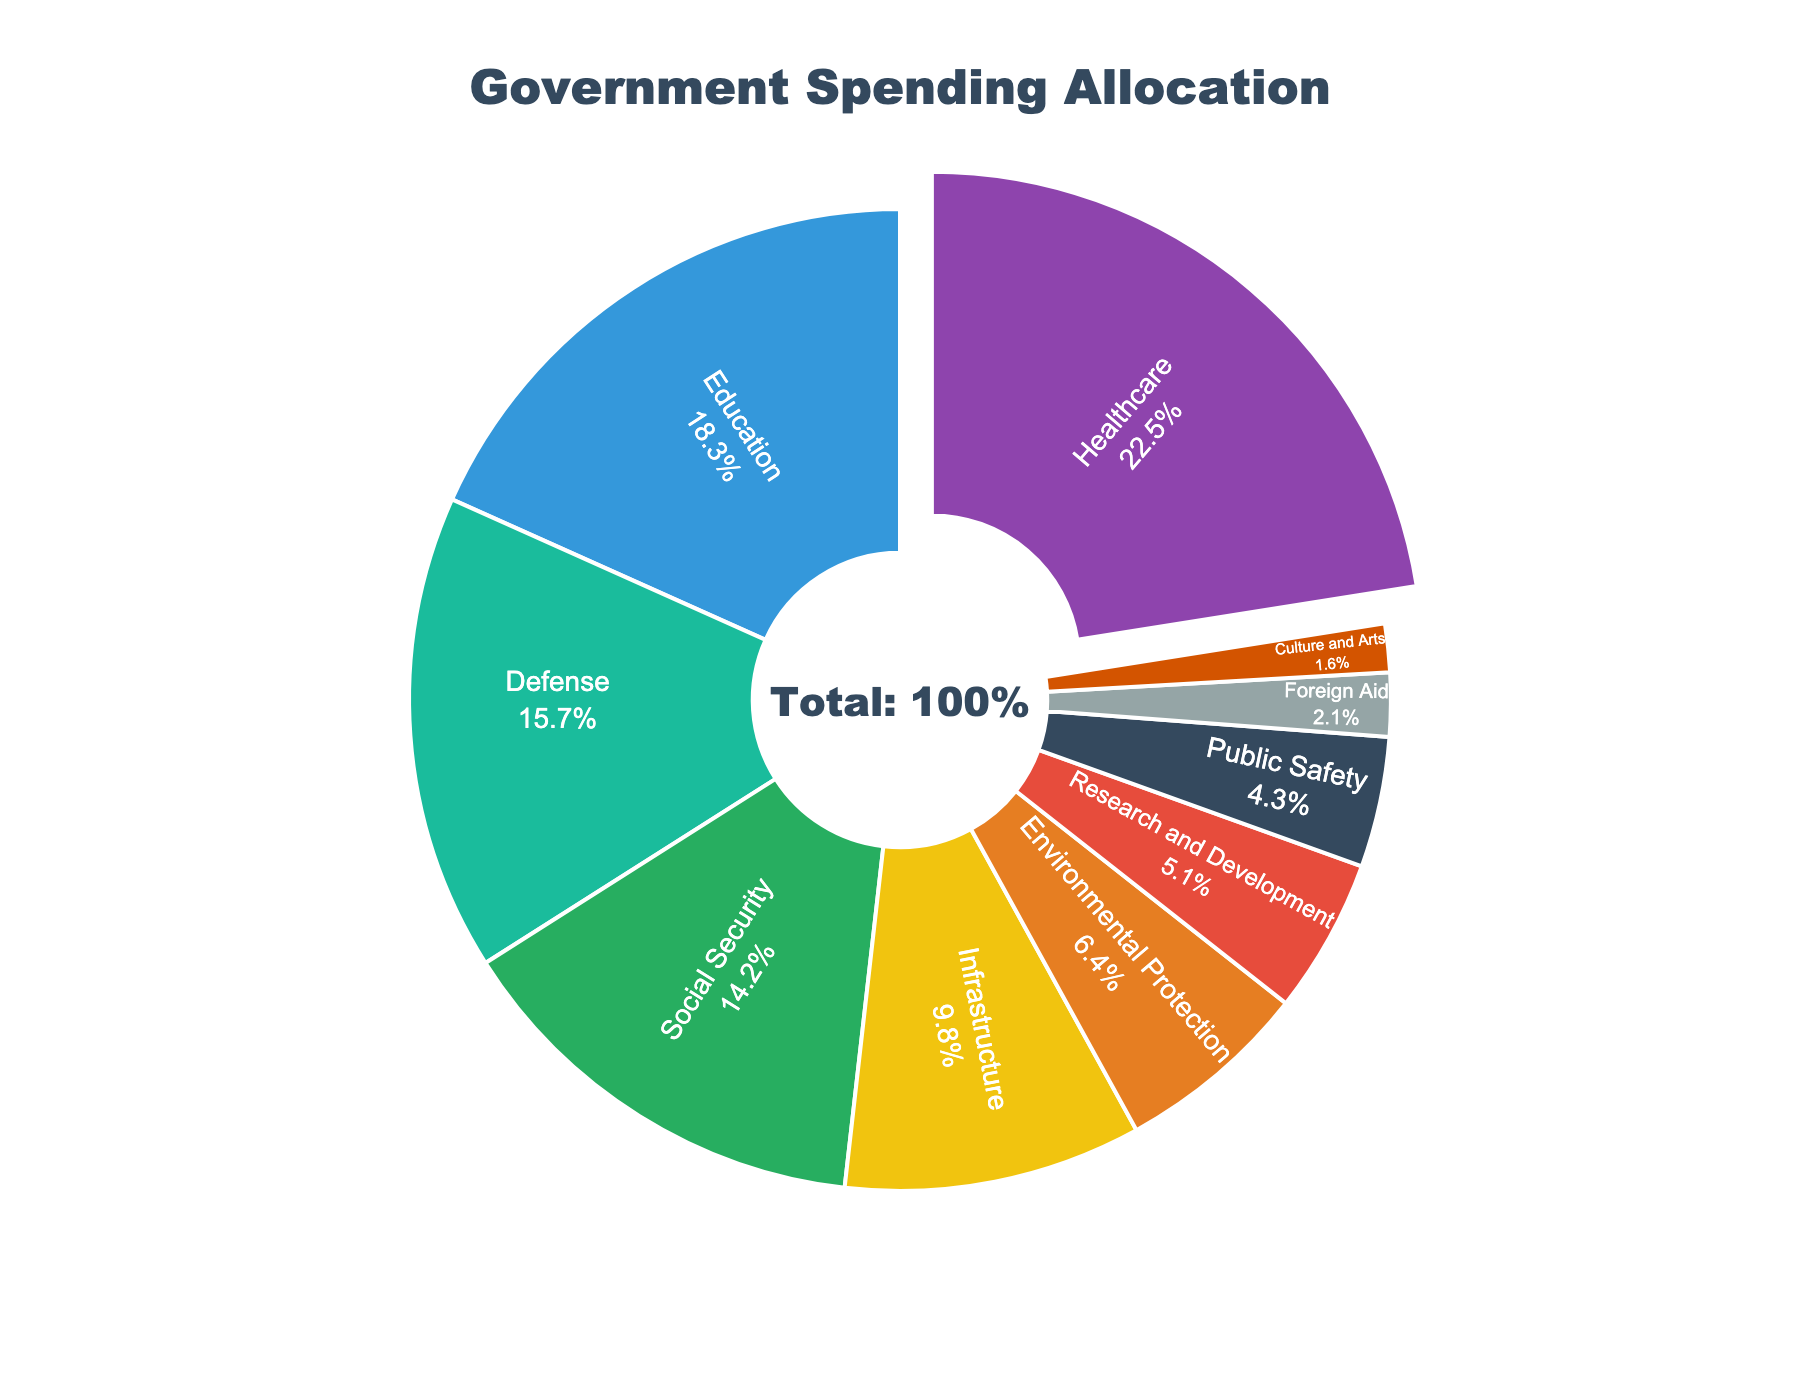What's the total percentage of spending on Education and Healthcare combined? To find the combined percentage, add the percentages of Education (18.3%) and Healthcare (22.5%). This gives 18.3 + 22.5 = 40.8%.
Answer: 40.8% Which sector receives the least amount of funding? Look at the sectors and their allocated percentages to find the smallest percentage value. Culture and Arts has the smallest allocation at 1.6%.
Answer: Culture and Arts Is more money spent on Defense or Social Security? Compare the percentage values for Defense (15.7%) and Social Security (14.2%). Defense has a higher percentage.
Answer: Defense What is the percentage difference between Infrastructure and Research and Development spending? Subtract the percentage of Research and Development (5.1%) from Infrastructure (9.8%). 9.8 - 5.1 = 4.7
Answer: 4.7% Which sector's slice is visually the largest, and by how much is it larger than the second-largest sector? By visually inspecting the pie chart, the Healthcare slice is the largest. The second-largest is Education. Calculate the difference: Healthcare (22.5%) - Education (18.3%) = 4.2.
Answer: Healthcare, 4.2% How many sectors have a percentage allocation greater than 10%? List the sectors and their percentages: Healthcare (22.5%), Education (18.3%), Defense (15.7%), Social Security (14.2%), and Infrastructure (9.8%). Only four sectors have percentages greater than 10%.
Answer: 4 Compare the funding allocated to Environmental Protection with Public Safety. Which one is higher and by how much? Compare Environmental Protection (6.4%) with Public Safety (4.3%). Environmental Protection is higher. 6.4 - 4.3 = 2.1.
Answer: Environmental Protection, 2.1% If the total government spending increased by 10% but the relative allocations remained the same, what would be the new percentage for Infrastructure? Assume the current total is 100%. An increase of 10% makes the new total 110%. The percentage for Infrastructure would be recalculated as (9.8/100)*110 = 10.78%
Answer: 10.78% Which sector is depicted in green, and what is its percentage allocation? By visually attributing the colors to the sectors and checking the pie chart, Defense is depicted in green, with a percentage allocation of 15.7%.
Answer: Defense, 15.7% Is spending on Foreign Aid more than double the spending on Culture and Arts? Compare Foreign Aid (2.1%) with Culture and Arts (1.6%) and double Culture and Arts' percentage: 1.6 * 2 = 3.2. Since 2.1 is less than 3.2, Foreign Aid is not more than double.
Answer: No 